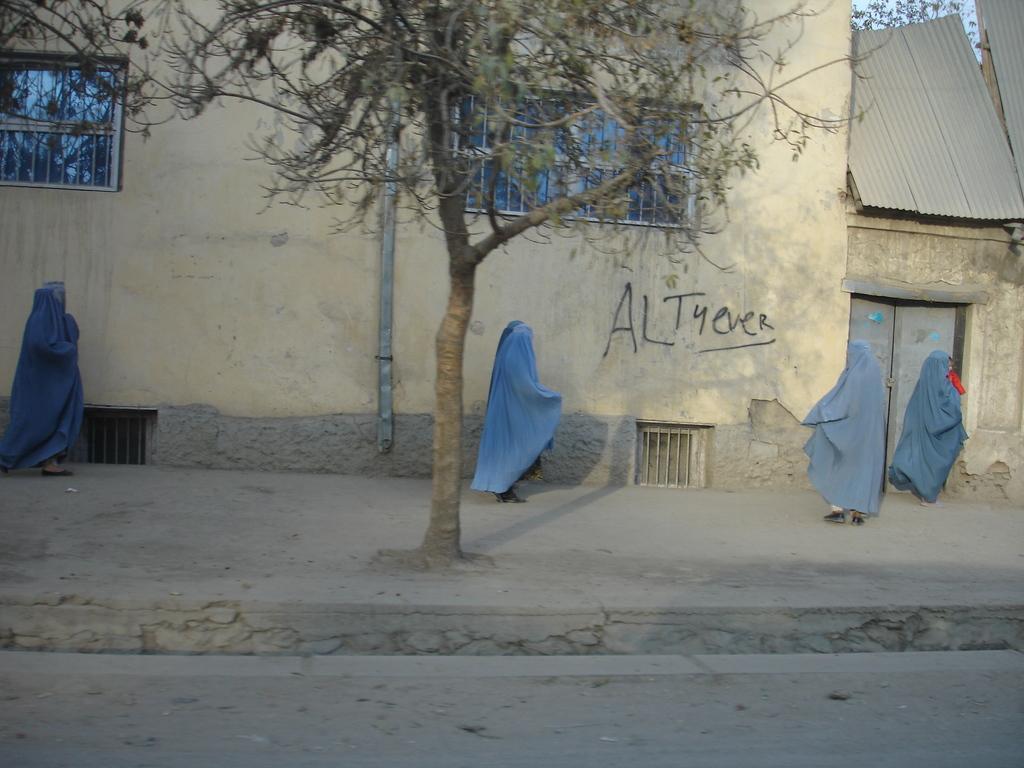How would you summarize this image in a sentence or two? In this picture, we see four people who are wearing the blue dresses are walking. In the middle of the picture, we see a tree. At the bottom, we see the pavement. In the background, we see a building or a wall on which some text is written. We even see the windows. On the right side, we see a building with a grey color roof. It has a door. Behind that, we see a tree. The person on the right side is holding a baby. 